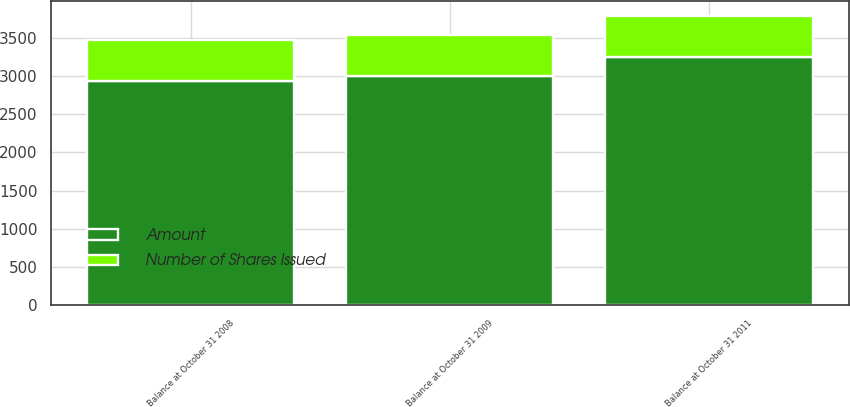<chart> <loc_0><loc_0><loc_500><loc_500><stacked_bar_chart><ecel><fcel>Balance at October 31 2008<fcel>Balance at October 31 2009<fcel>Balance at October 31 2011<nl><fcel>Number of Shares Issued<fcel>536.4<fcel>536.4<fcel>536.4<nl><fcel>Amount<fcel>2934<fcel>2996<fcel>3252<nl></chart> 